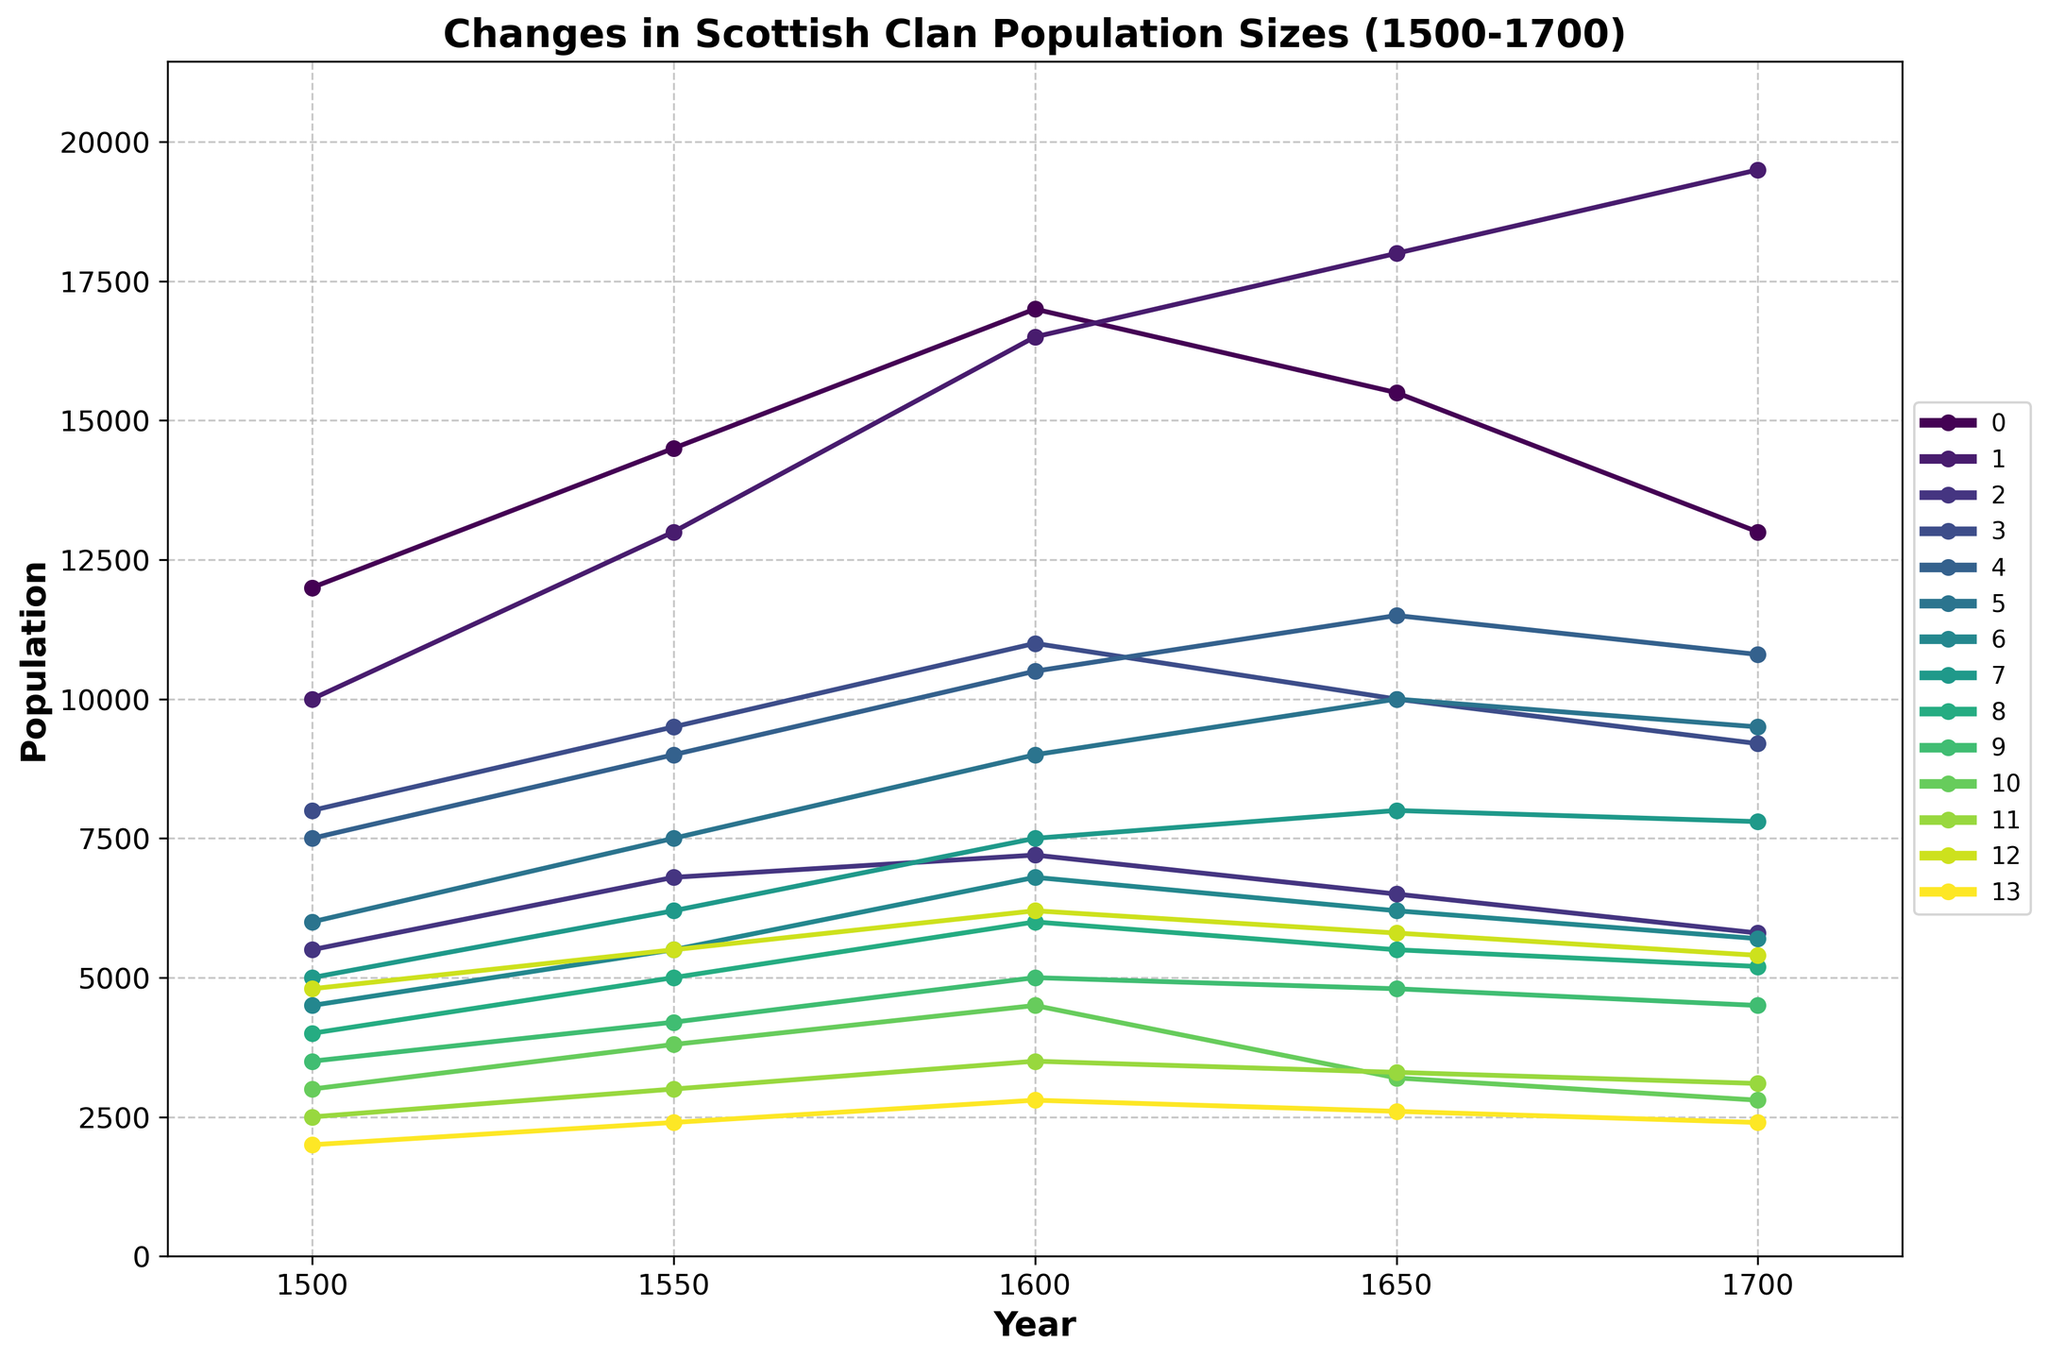Which clan experienced the greatest population growth between 1500 and 1600? To find the clan with the greatest population growth between 1500 and 1600, subtract the population in 1500 from the population in 1600 for each clan. The differences are: Clan MacDonald (17000-12000=5000), Clan Campbell (16500-10000=6500), Clan MacLeod (7200-5500=1700), Clan Stewart (11000-8000=3000), Clan Gordon (10500-7500=3000), Clan MacKenzie (9000-6000=3000), Clan Cameron (6800-4500=2300), Clan Murray (7500-5000=2500), Clan Fraser (6000-4000=2000), Clan Sinclair (5000-3500=1500), Clan MacGregor (4500-3000=1500), Clan Chisholm (3500-2500=1000), Clan MacLean (6200-4800=1400), Clan Gunn (2800-2000=800). Clan Campbell has the highest increase of 6500.
Answer: Clan Campbell Which clan had the lowest population in 1700? Look at the population sizes in 1700 for all clans and identify the smallest number: Clan MacDonald (13000), Clan Campbell (19500), Clan MacLeod (5800), Clan Stewart (9200), Clan Gordon (10800), Clan MacKenzie (9500), Clan Cameron (5700), Clan Murray (7800), Clan Fraser (5200), Clan Sinclair (4500), Clan MacGregor (2800), Clan Chisholm (3100), Clan MacLean (5400), Clan Gunn (2400). The smallest population is for Clan Gunn with 2400.
Answer: Clan Gunn How did the population size of Clan MacDonald compare to Clan Campbell in 1700? In 1700, Clan MacDonald had a population size of 13000, and Clan Campbell had a population size of 19500. To compare, subtract Clan MacDonald's population from Clan Campbell's: 19500 - 13000 = 6500. Clan Campbell was larger than Clan MacDonald by 6500.
Answer: Clan Campbell was larger by 6500 Which clans had a lower population in 1700 compared to 1650? Compare the population sizes for each clan between 1650 and 1700: Clan MacDonald (16500-13000=2500), Clan Campbell (18000-19500=-1500), Clan MacLeod (6500-5800=700), Clan Stewart (10000-9200=800), Clan Gordon (11500-10800=700), Clan MacKenzie (10000-9500=500), Clan Cameron (6200-5700=500), Clan Murray (8000-7800=200), Clan Fraser (5500-5200=300), Clan Sinclair (4800-4500=300), Clan MacGregor (3200-2800=400), Clan Chisholm (3300-3100=200), Clan MacLean (5800-5400=400), Clan Gunn (2600-2400=200). Clans with lower populations are Clan MacDonald, Clan MacLeod, Clan Stewart, Clan Gordon, Clan MacKenzie, Clan Cameron, Clan Fraser, Clan Sinclair, Clan MacGregor, Clan Chisholm, Clan MacLean, and Clan Gunn.
Answer: Clan MacDonald, Clan MacLeod, Clan Stewart, Clan Gordon, Clan MacKenzie, Clan Cameron, Clan Fraser, Clan Sinclair, Clan MacGregor, Clan Chisholm, Clan MacLean, Clan Gunn What is the average population of Clan Gordon across the years? To find the average population size of Clan Gordon, sum the populations for 1500, 1550, 1600, 1650, and 1700, and divide by the number of years: (7500+9000+10500+11500+10800) / 5 = 49300 / 5 = 9860
Answer: 9860 By how much did Clan MacGregor's population change from 1500 to 1700? Subtract the population in 1700 from the population in 1500 for Clan MacGregor: 2800 - 3000 = -200. The population decreased by 200.
Answer: Decreased by 200 Which clan had the most stable population (smallest range) over the period from 1500 to 1700? Calculate the population range for each clan by subtracting the smallest population value from the largest over the given years. For example, for Clan MacDonald: max(12000, 14500, 17000, 15500, 13000) - min(12000, 14500, 17000, 15500, 13000) = 17000 - 12000 = 5000. Calculate similarly for all clans and compare the ranges: Clan MacDonald (5000), Clan Campbell (9500), Clan MacLeod (1700), Clan Stewart (3000), Clan Gordon (4000), Clan MacKenzie (4000), Clan Cameron (2300), Clan Murray (3000), Clan Fraser (2000), Clan Sinclair (1500), Clan MacGregor (1500), Clan Chisholm (1000), Clan MacLean (1400), Clan Gunn (800). Clan Chisholm had the smallest range of 1000.
Answer: Clan Chisholm 